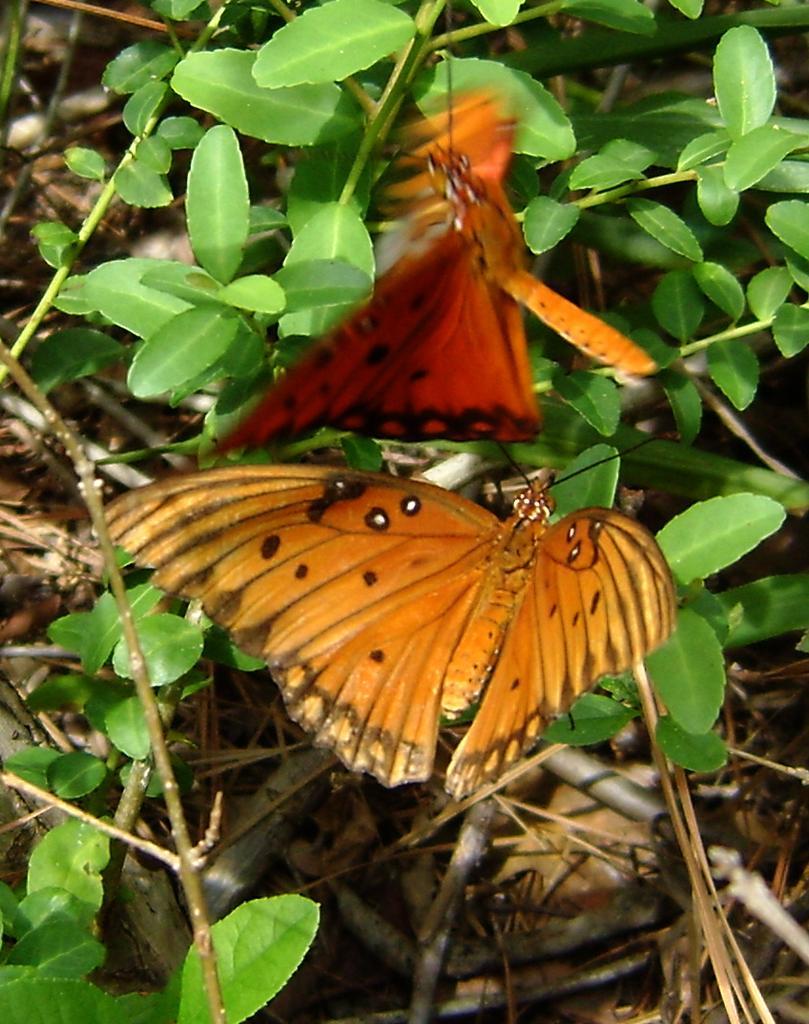Can you describe this image briefly? In this image there are butterflies and there are plants. 